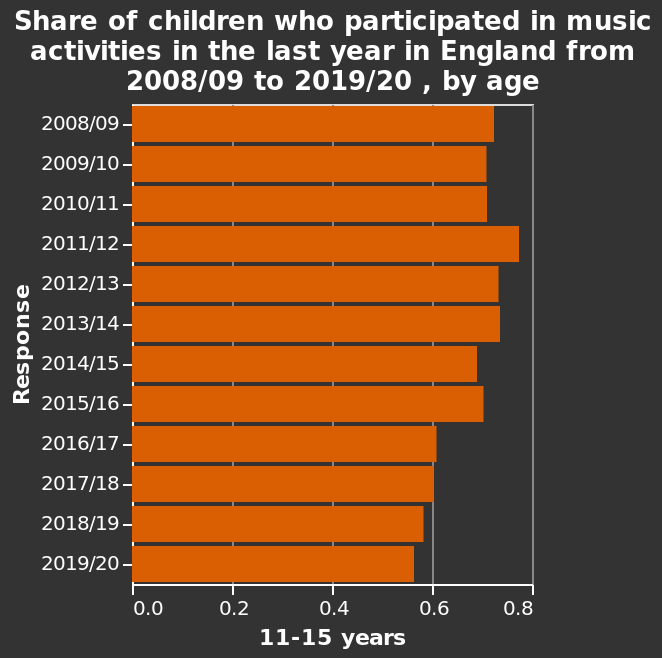<image>
What is the time period covered by the bar graph? The bar graph covers the time period from 2008/09 to 2019/20. 